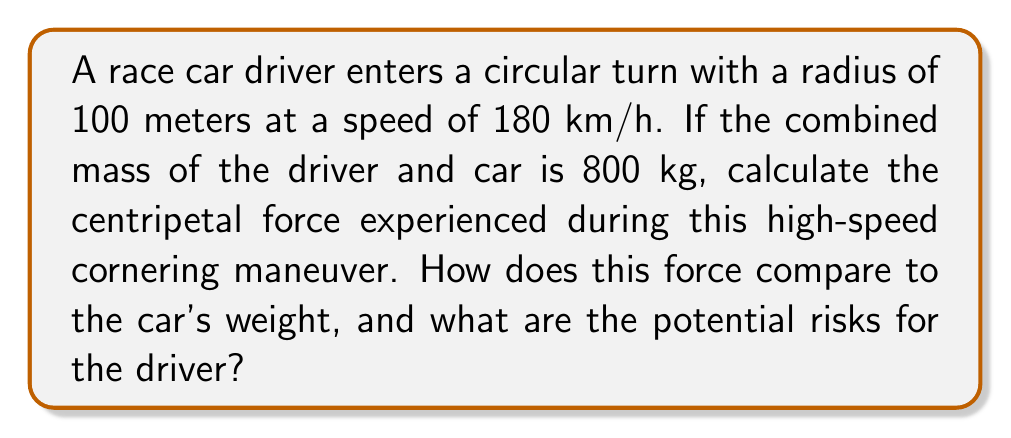Can you solve this math problem? Let's approach this step-by-step:

1) First, we need to convert the speed from km/h to m/s:
   $180 \text{ km/h} = 180 \times \frac{1000 \text{ m}}{3600 \text{ s}} = 50 \text{ m/s}$

2) The formula for centripetal force is:
   $$F_c = \frac{mv^2}{r}$$
   Where:
   $F_c$ is the centripetal force
   $m$ is the mass
   $v$ is the velocity
   $r$ is the radius of the turn

3) Let's substitute our values:
   $$F_c = \frac{800 \text{ kg} \times (50 \text{ m/s})^2}{100 \text{ m}}$$

4) Calculate:
   $$F_c = \frac{800 \times 2500}{100} = 20,000 \text{ N} = 20 \text{ kN}$$

5) To compare this to the car's weight:
   Weight = mass × gravity
   $W = 800 \text{ kg} \times 9.8 \text{ m/s}^2 = 7,840 \text{ N} \approx 7.84 \text{ kN}$

6) The centripetal force is about 2.55 times the weight of the car.

Potential risks for the driver:
- Extreme G-forces could lead to loss of consciousness
- Increased likelihood of losing control of the vehicle
- Higher risk of rollover due to the large lateral force
- Increased tire wear and potential for tire failure
- Greater stress on the car's suspension and chassis
Answer: 20 kN, 2.55 times the car's weight 